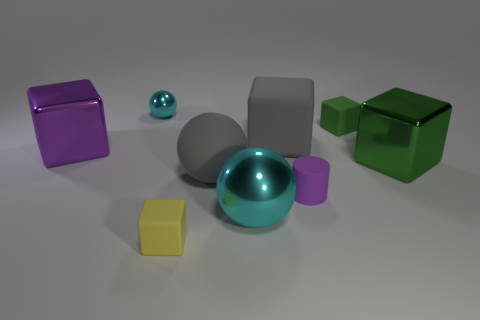What materials do the objects in this image seem to be made of? Based on the visual appearance, the objects seem to be made of different materials. The yellow block and the purple cube exhibit matte surfaces, indicating they could be made of plastic or perhaps coated in a non-reflective paint. The turquoise and smaller grey spheres have reflective surfaces, suggesting they might be made of polished metal or glass. 